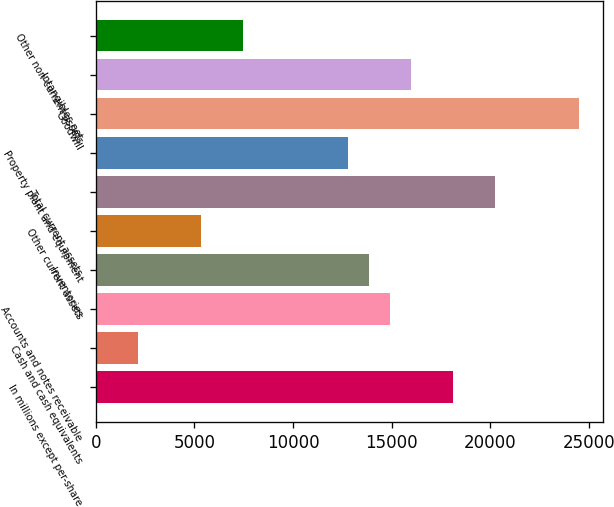Convert chart. <chart><loc_0><loc_0><loc_500><loc_500><bar_chart><fcel>In millions except per-share<fcel>Cash and cash equivalents<fcel>Accounts and notes receivable<fcel>Inventories<fcel>Other current assets<fcel>Total current assets<fcel>Property plant and equipment<fcel>Goodwill<fcel>Intangibles net<fcel>Other non-current assets<nl><fcel>18112.4<fcel>2132.64<fcel>14916.5<fcel>13851.2<fcel>5328.6<fcel>20243.1<fcel>12785.8<fcel>24504.4<fcel>15981.8<fcel>7459.24<nl></chart> 